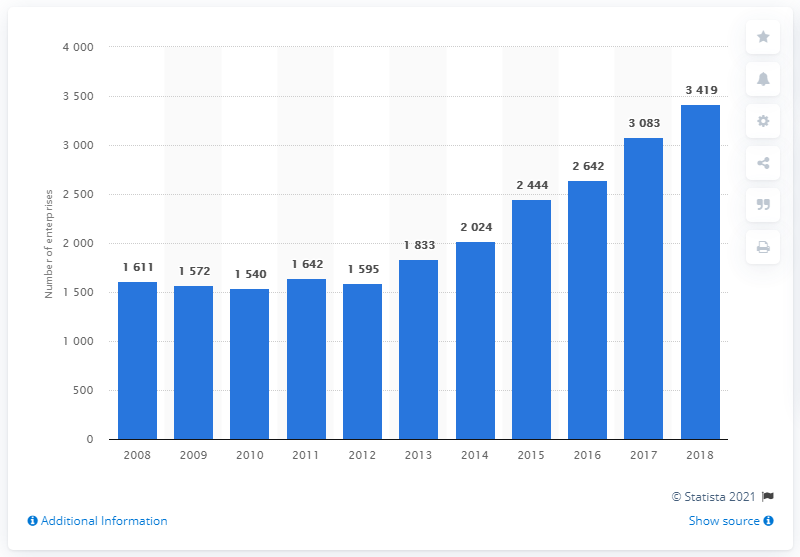Mention a couple of crucial points in this snapshot. In 2018, there were 3,419 fitness facilities in the United Kingdom. 